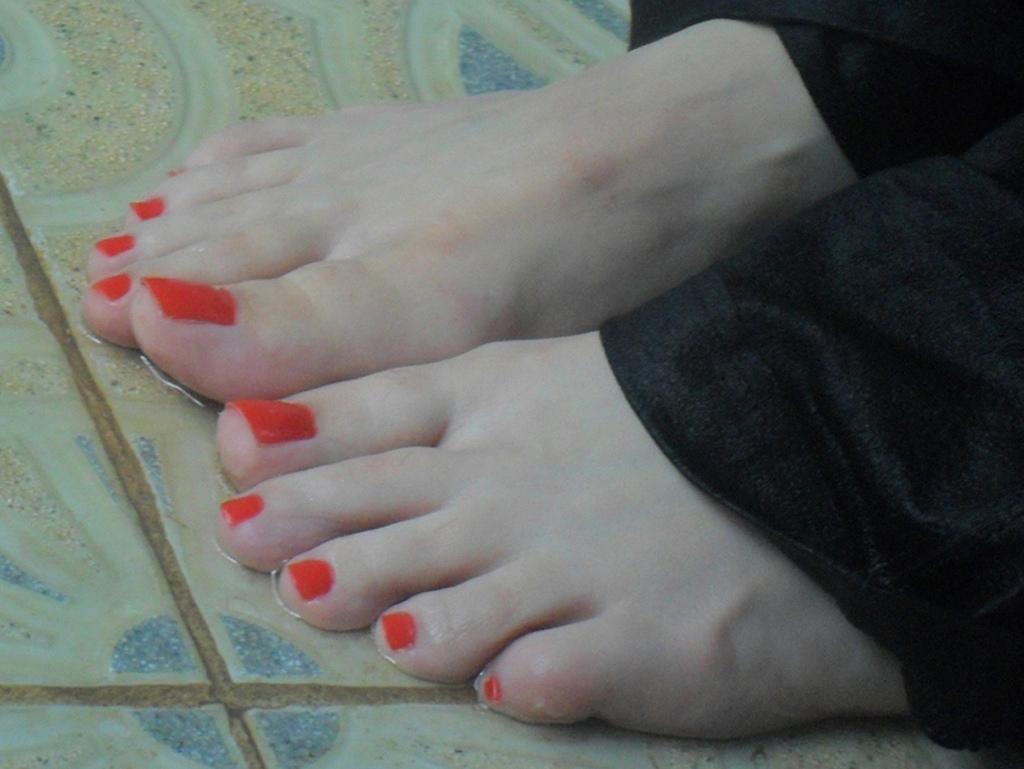What part of a person can be seen in the image? There are legs of a person in the image. What detail can be observed about the person's nails? The person has reddish orange color nail polish on their nails. Is there a scarf wrapped around the person's neck in the image? There is no mention of a scarf or any other clothing item in the image, so it cannot be determined if the person is wearing a scarf. 